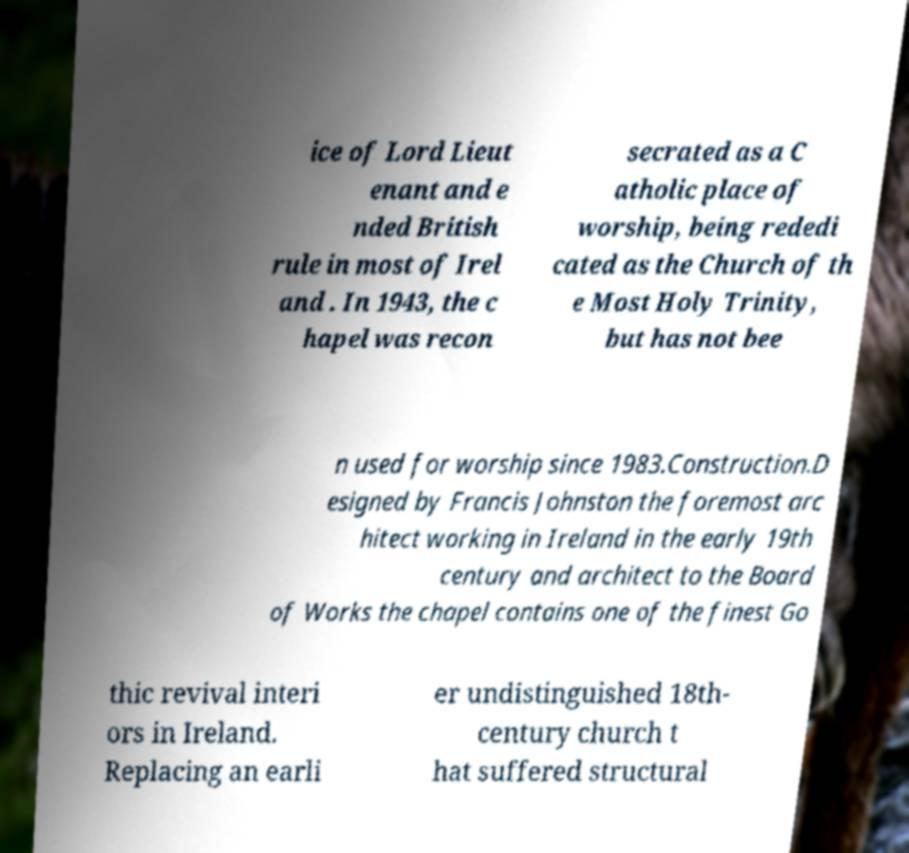Please read and relay the text visible in this image. What does it say? ice of Lord Lieut enant and e nded British rule in most of Irel and . In 1943, the c hapel was recon secrated as a C atholic place of worship, being rededi cated as the Church of th e Most Holy Trinity, but has not bee n used for worship since 1983.Construction.D esigned by Francis Johnston the foremost arc hitect working in Ireland in the early 19th century and architect to the Board of Works the chapel contains one of the finest Go thic revival interi ors in Ireland. Replacing an earli er undistinguished 18th- century church t hat suffered structural 